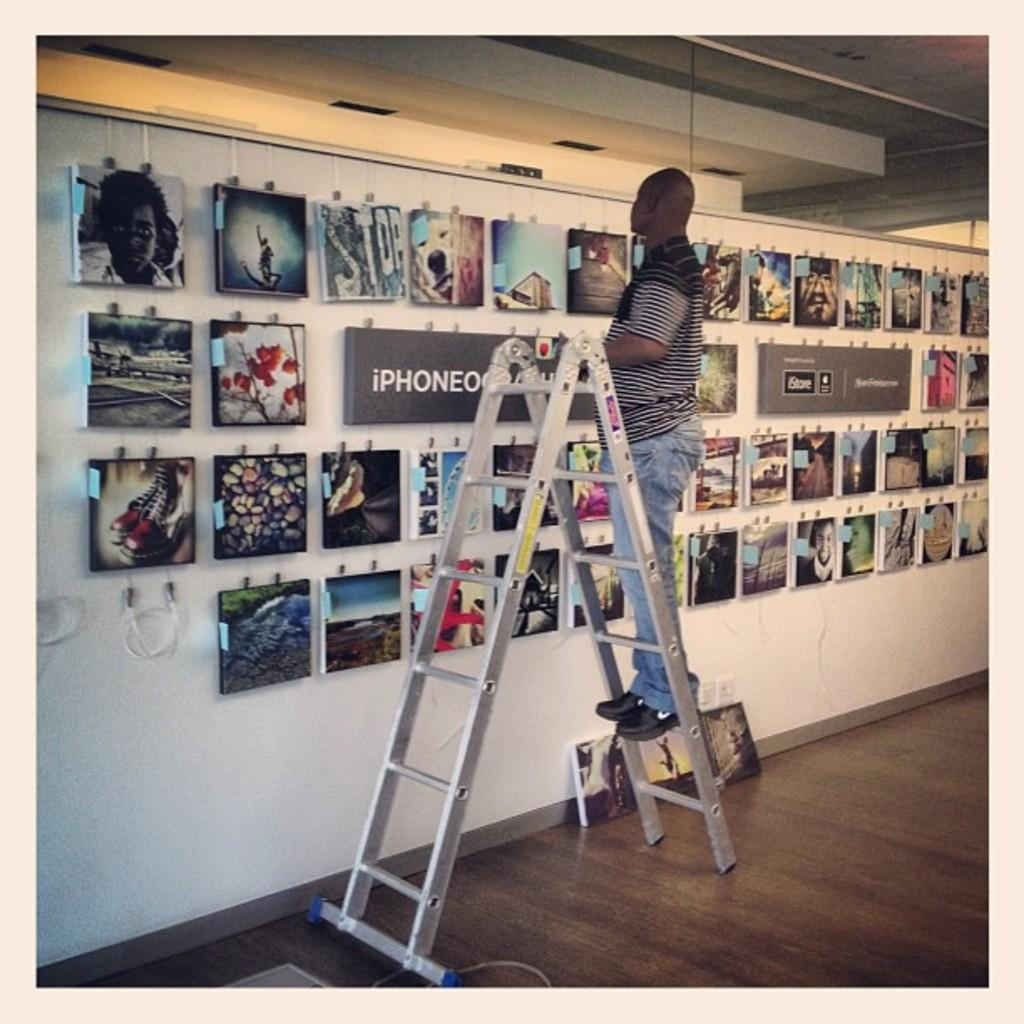<image>
Present a compact description of the photo's key features. Art work displayed on the wall with a grey frame in the middle with iphone on it. 